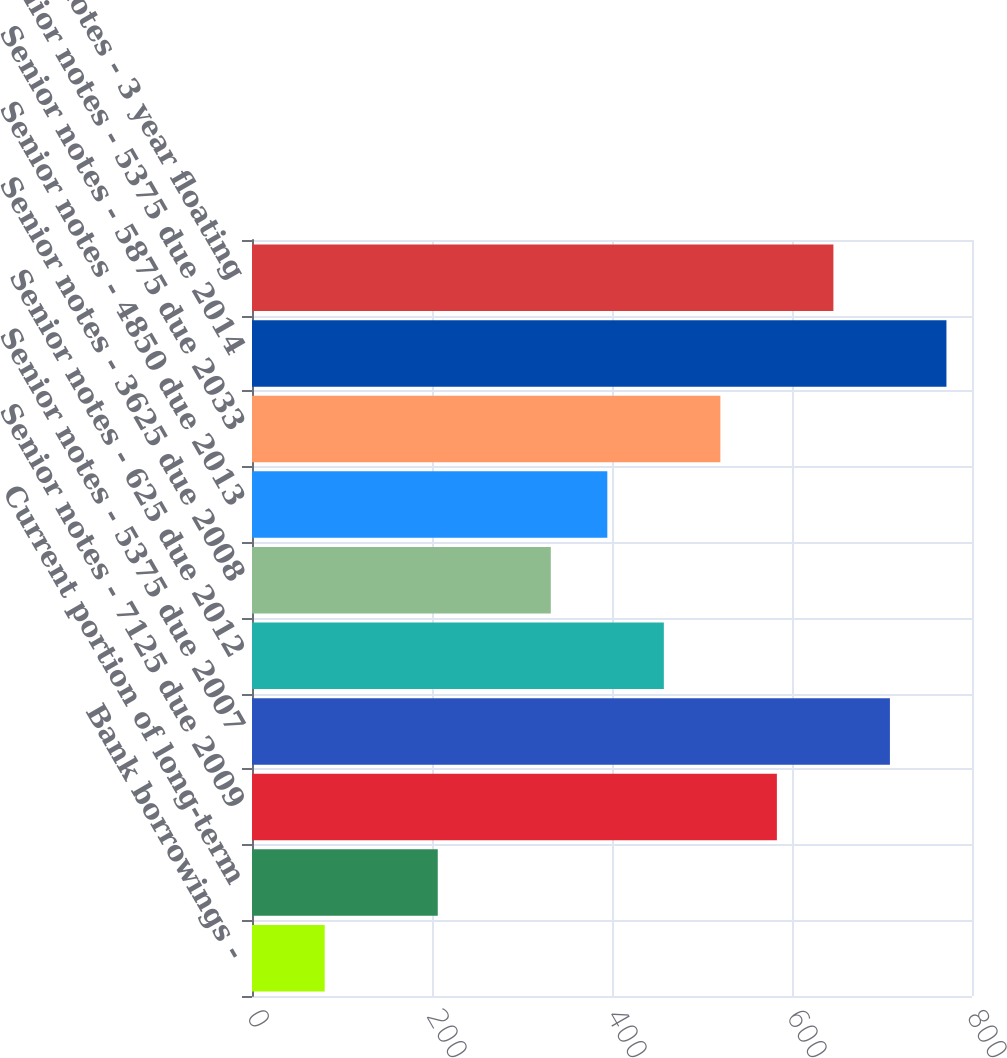Convert chart to OTSL. <chart><loc_0><loc_0><loc_500><loc_500><bar_chart><fcel>Bank borrowings -<fcel>Current portion of long-term<fcel>Senior notes - 7125 due 2009<fcel>Senior notes - 5375 due 2007<fcel>Senior notes - 625 due 2012<fcel>Senior notes - 3625 due 2008<fcel>Senior notes - 4850 due 2013<fcel>Senior notes - 5875 due 2033<fcel>Senior notes - 5375 due 2014<fcel>Senior notes - 3 year floating<nl><fcel>80.8<fcel>206.4<fcel>583.2<fcel>708.8<fcel>457.6<fcel>332<fcel>394.8<fcel>520.4<fcel>771.6<fcel>646<nl></chart> 